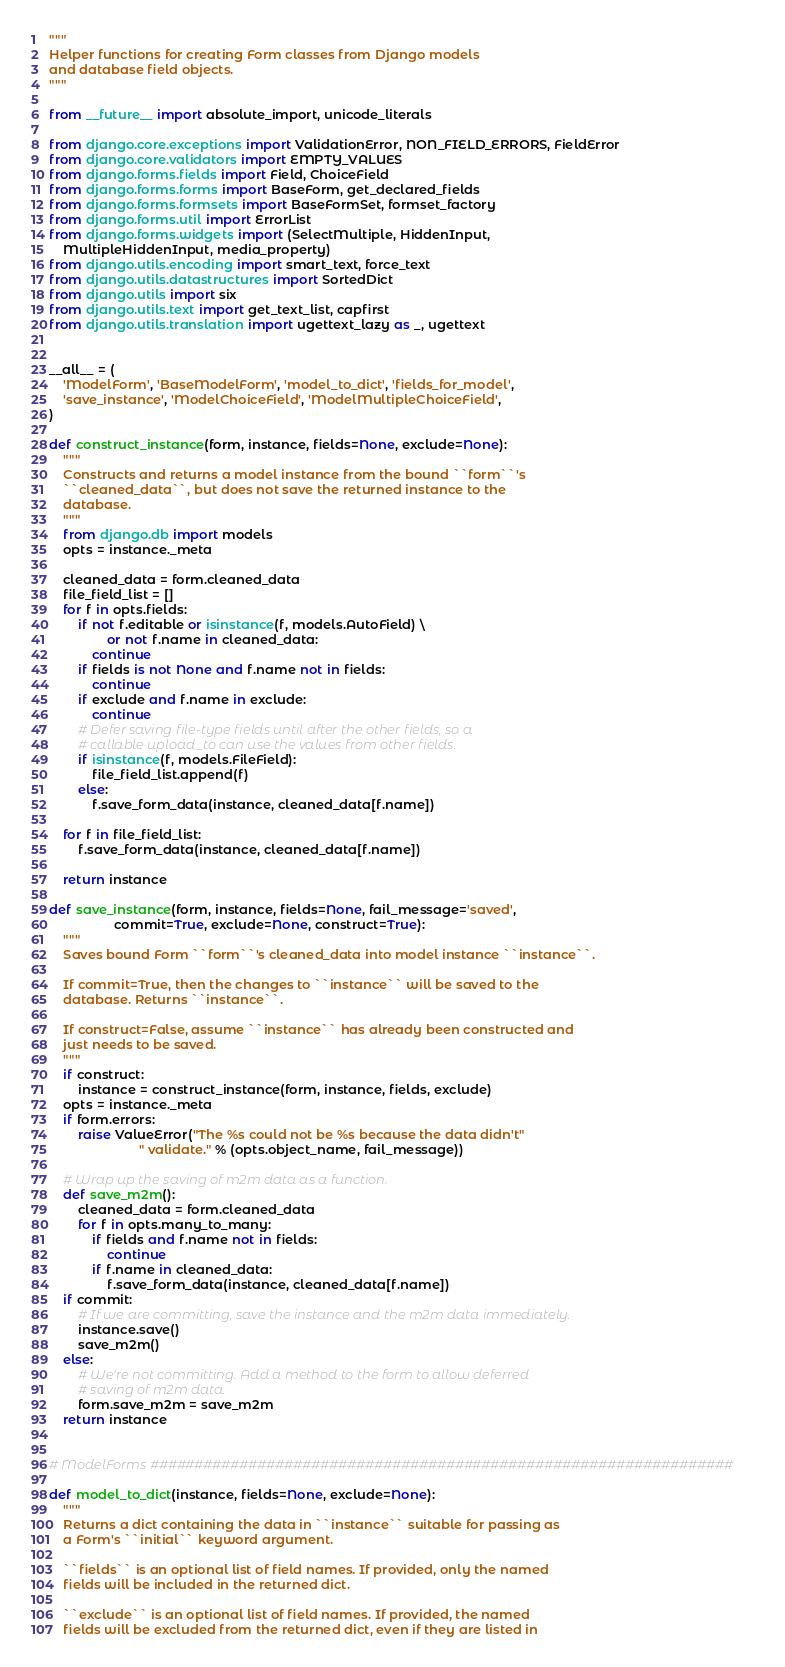<code> <loc_0><loc_0><loc_500><loc_500><_Python_>"""
Helper functions for creating Form classes from Django models
and database field objects.
"""

from __future__ import absolute_import, unicode_literals

from django.core.exceptions import ValidationError, NON_FIELD_ERRORS, FieldError
from django.core.validators import EMPTY_VALUES
from django.forms.fields import Field, ChoiceField
from django.forms.forms import BaseForm, get_declared_fields
from django.forms.formsets import BaseFormSet, formset_factory
from django.forms.util import ErrorList
from django.forms.widgets import (SelectMultiple, HiddenInput,
    MultipleHiddenInput, media_property)
from django.utils.encoding import smart_text, force_text
from django.utils.datastructures import SortedDict
from django.utils import six
from django.utils.text import get_text_list, capfirst
from django.utils.translation import ugettext_lazy as _, ugettext


__all__ = (
    'ModelForm', 'BaseModelForm', 'model_to_dict', 'fields_for_model',
    'save_instance', 'ModelChoiceField', 'ModelMultipleChoiceField',
)

def construct_instance(form, instance, fields=None, exclude=None):
    """
    Constructs and returns a model instance from the bound ``form``'s
    ``cleaned_data``, but does not save the returned instance to the
    database.
    """
    from django.db import models
    opts = instance._meta

    cleaned_data = form.cleaned_data
    file_field_list = []
    for f in opts.fields:
        if not f.editable or isinstance(f, models.AutoField) \
                or not f.name in cleaned_data:
            continue
        if fields is not None and f.name not in fields:
            continue
        if exclude and f.name in exclude:
            continue
        # Defer saving file-type fields until after the other fields, so a
        # callable upload_to can use the values from other fields.
        if isinstance(f, models.FileField):
            file_field_list.append(f)
        else:
            f.save_form_data(instance, cleaned_data[f.name])

    for f in file_field_list:
        f.save_form_data(instance, cleaned_data[f.name])

    return instance

def save_instance(form, instance, fields=None, fail_message='saved',
                  commit=True, exclude=None, construct=True):
    """
    Saves bound Form ``form``'s cleaned_data into model instance ``instance``.

    If commit=True, then the changes to ``instance`` will be saved to the
    database. Returns ``instance``.

    If construct=False, assume ``instance`` has already been constructed and
    just needs to be saved.
    """
    if construct:
        instance = construct_instance(form, instance, fields, exclude)
    opts = instance._meta
    if form.errors:
        raise ValueError("The %s could not be %s because the data didn't"
                         " validate." % (opts.object_name, fail_message))

    # Wrap up the saving of m2m data as a function.
    def save_m2m():
        cleaned_data = form.cleaned_data
        for f in opts.many_to_many:
            if fields and f.name not in fields:
                continue
            if f.name in cleaned_data:
                f.save_form_data(instance, cleaned_data[f.name])
    if commit:
        # If we are committing, save the instance and the m2m data immediately.
        instance.save()
        save_m2m()
    else:
        # We're not committing. Add a method to the form to allow deferred
        # saving of m2m data.
        form.save_m2m = save_m2m
    return instance


# ModelForms #################################################################

def model_to_dict(instance, fields=None, exclude=None):
    """
    Returns a dict containing the data in ``instance`` suitable for passing as
    a Form's ``initial`` keyword argument.

    ``fields`` is an optional list of field names. If provided, only the named
    fields will be included in the returned dict.

    ``exclude`` is an optional list of field names. If provided, the named
    fields will be excluded from the returned dict, even if they are listed in</code> 